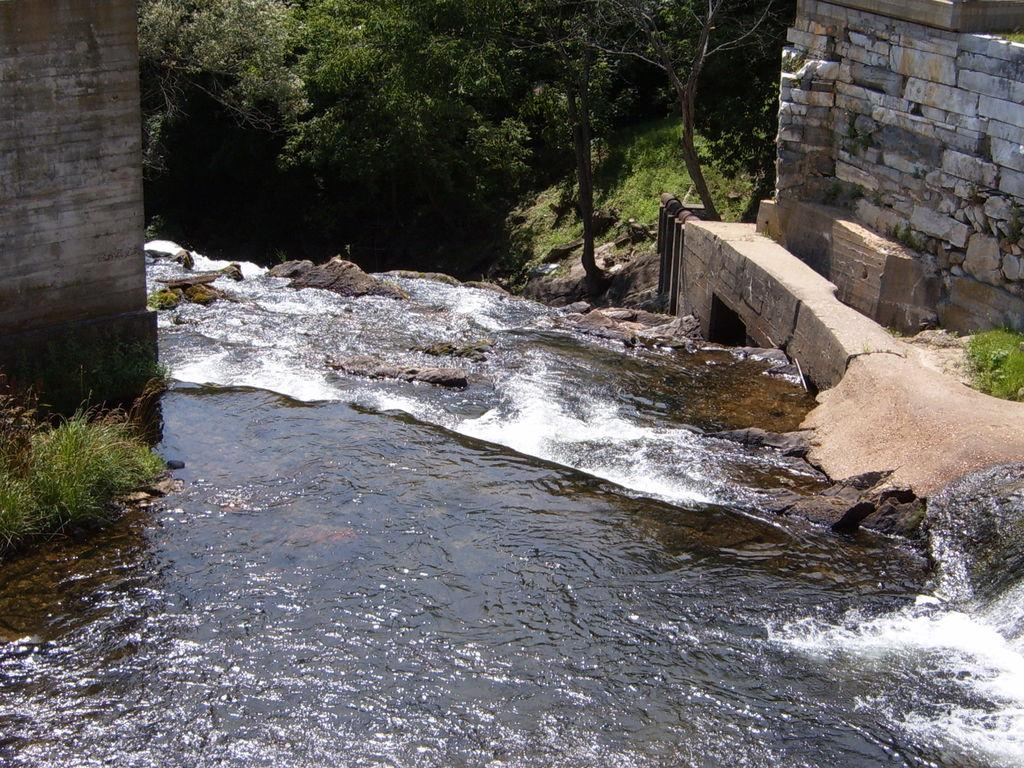What is visible in the image? Water is visible in the image. What can be seen in the background of the image? There are trees and a wall visible in the background of the image. What is the color of the trees in the image? The trees are green in color. Where is the sofa located in the image? There is no sofa present in the image. What part of the laborer's body can be seen in the image? There is no laborer present in the image. 